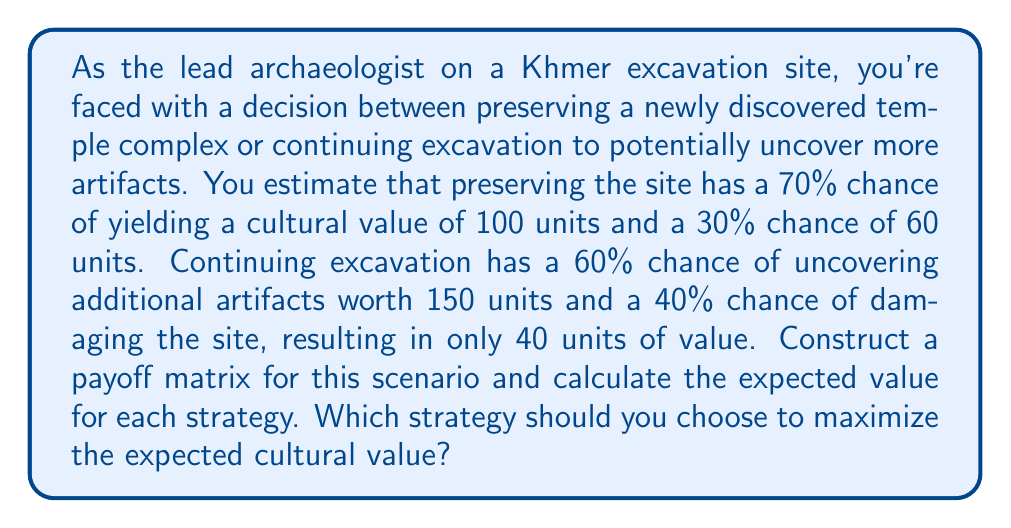What is the answer to this math problem? Let's approach this problem step-by-step:

1. First, we need to construct the payoff matrix based on the given information:

   $$
   \begin{array}{c|c|c}
   & \text{Success} & \text{Failure} \\
   \hline
   \text{Preserve} & 100 & 60 \\
   \hline
   \text{Excavate} & 150 & 40 \\
   \end{array}
   $$

2. Now, we need to calculate the expected value for each strategy:

   For Preservation:
   $$E(\text{Preserve}) = 0.70 \times 100 + 0.30 \times 60 = 70 + 18 = 88$$

   For Excavation:
   $$E(\text{Excavate}) = 0.60 \times 150 + 0.40 \times 40 = 90 + 16 = 106$$

3. To make the optimal decision, we compare the expected values:

   $$E(\text{Excavate}) = 106 > E(\text{Preserve}) = 88$$

4. The strategy with the higher expected value is excavation, with an expected cultural value of 106 units.

This analysis shows that despite the risk of damaging the site, the potential reward of uncovering additional artifacts outweighs the safer option of preservation in terms of expected cultural value.
Answer: The optimal strategy is to continue excavation, which has an expected cultural value of 106 units compared to 88 units for preservation. 